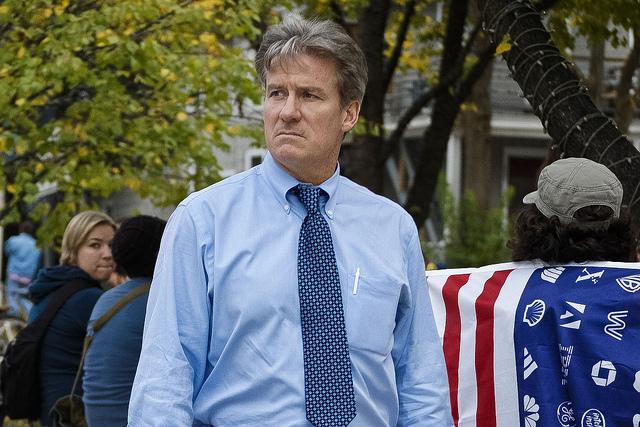What color is his outfit?
Short answer required. Blue. Are both the buttons on the man suit buttoned?
Be succinct. Yes. Is the man talking on the phone?
Short answer required. No. Where is the pen?
Keep it brief. Pocket. Is the man overweight?
Be succinct. No. Is this man an actor?
Be succinct. No. What has replaced the stars on the union of the flag?
Give a very brief answer. Logos. This man can tie is correctly done?
Concise answer only. Yes. Do the people appear to be happy?
Write a very short answer. No. 